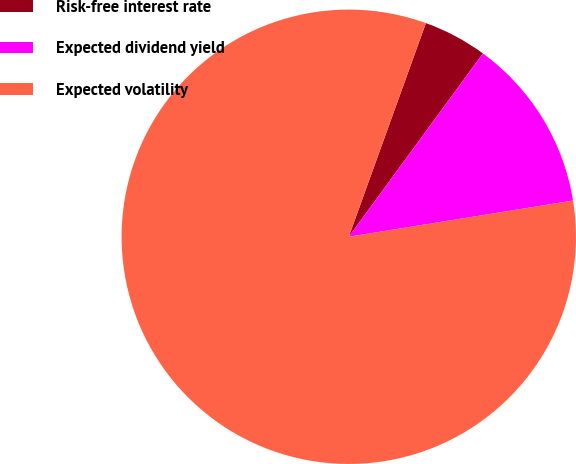<chart> <loc_0><loc_0><loc_500><loc_500><pie_chart><fcel>Risk-free interest rate<fcel>Expected dividend yield<fcel>Expected volatility<nl><fcel>4.54%<fcel>12.4%<fcel>83.07%<nl></chart> 